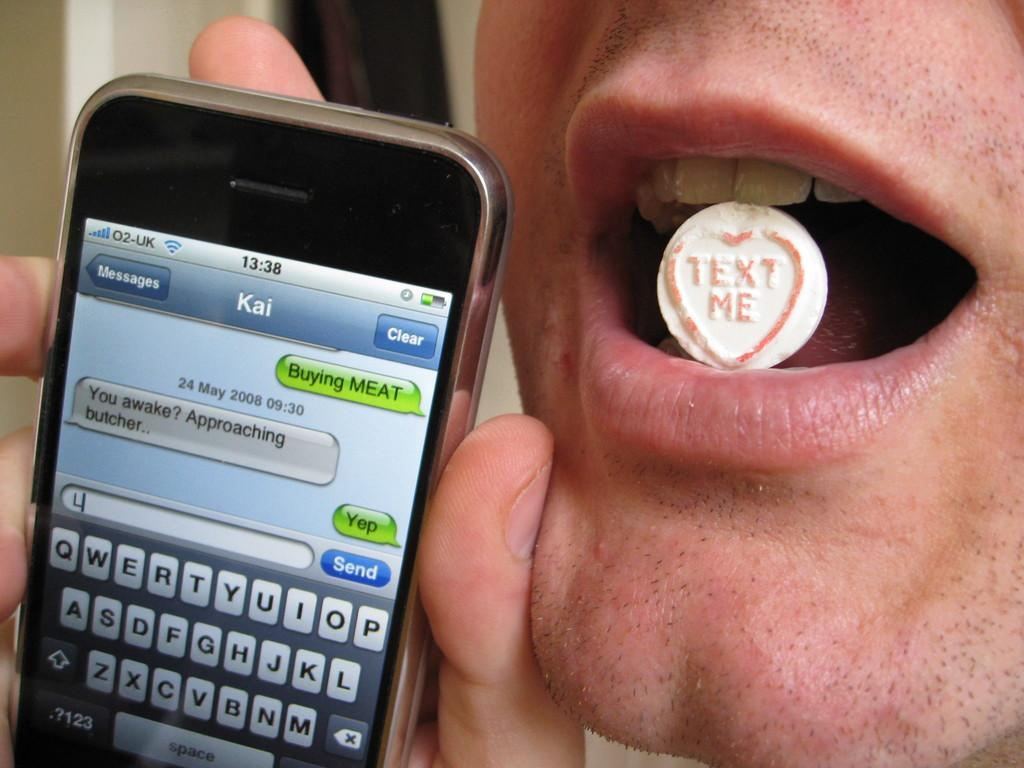Provide a one-sentence caption for the provided image. A man is holding a cell phone to his face and has placed a heart shaped token with the words text me in his mouth. 